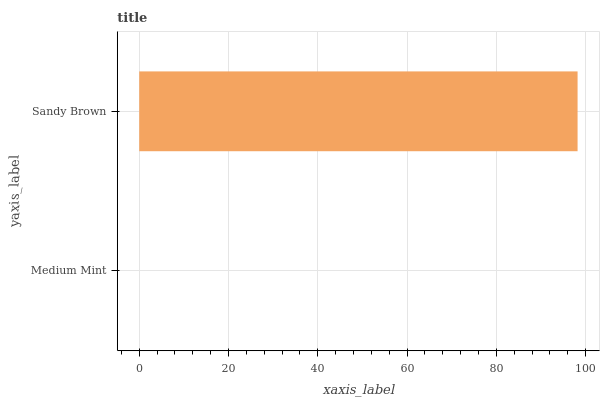Is Medium Mint the minimum?
Answer yes or no. Yes. Is Sandy Brown the maximum?
Answer yes or no. Yes. Is Sandy Brown the minimum?
Answer yes or no. No. Is Sandy Brown greater than Medium Mint?
Answer yes or no. Yes. Is Medium Mint less than Sandy Brown?
Answer yes or no. Yes. Is Medium Mint greater than Sandy Brown?
Answer yes or no. No. Is Sandy Brown less than Medium Mint?
Answer yes or no. No. Is Sandy Brown the high median?
Answer yes or no. Yes. Is Medium Mint the low median?
Answer yes or no. Yes. Is Medium Mint the high median?
Answer yes or no. No. Is Sandy Brown the low median?
Answer yes or no. No. 